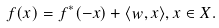Convert formula to latex. <formula><loc_0><loc_0><loc_500><loc_500>f ( x ) = f ^ { * } ( - x ) + \langle w , x \rangle , x \in X .</formula> 